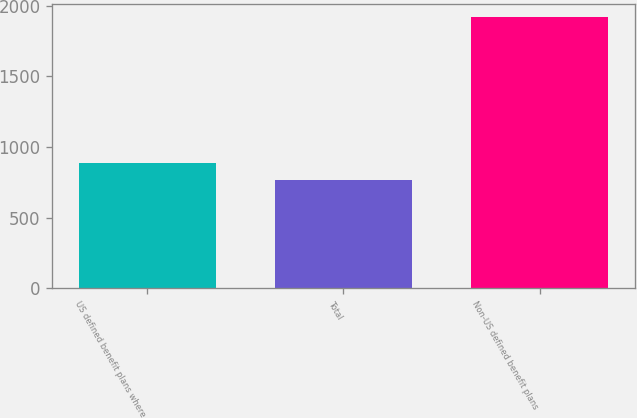<chart> <loc_0><loc_0><loc_500><loc_500><bar_chart><fcel>US defined benefit plans where<fcel>Total<fcel>Non-US defined benefit plans<nl><fcel>883.4<fcel>768.7<fcel>1915.7<nl></chart> 